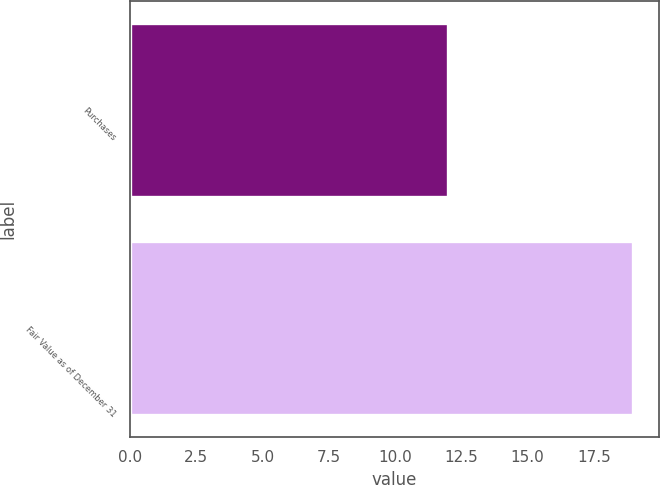Convert chart to OTSL. <chart><loc_0><loc_0><loc_500><loc_500><bar_chart><fcel>Purchases<fcel>Fair Value as of December 31<nl><fcel>12<fcel>19<nl></chart> 